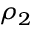Convert formula to latex. <formula><loc_0><loc_0><loc_500><loc_500>\rho _ { 2 }</formula> 